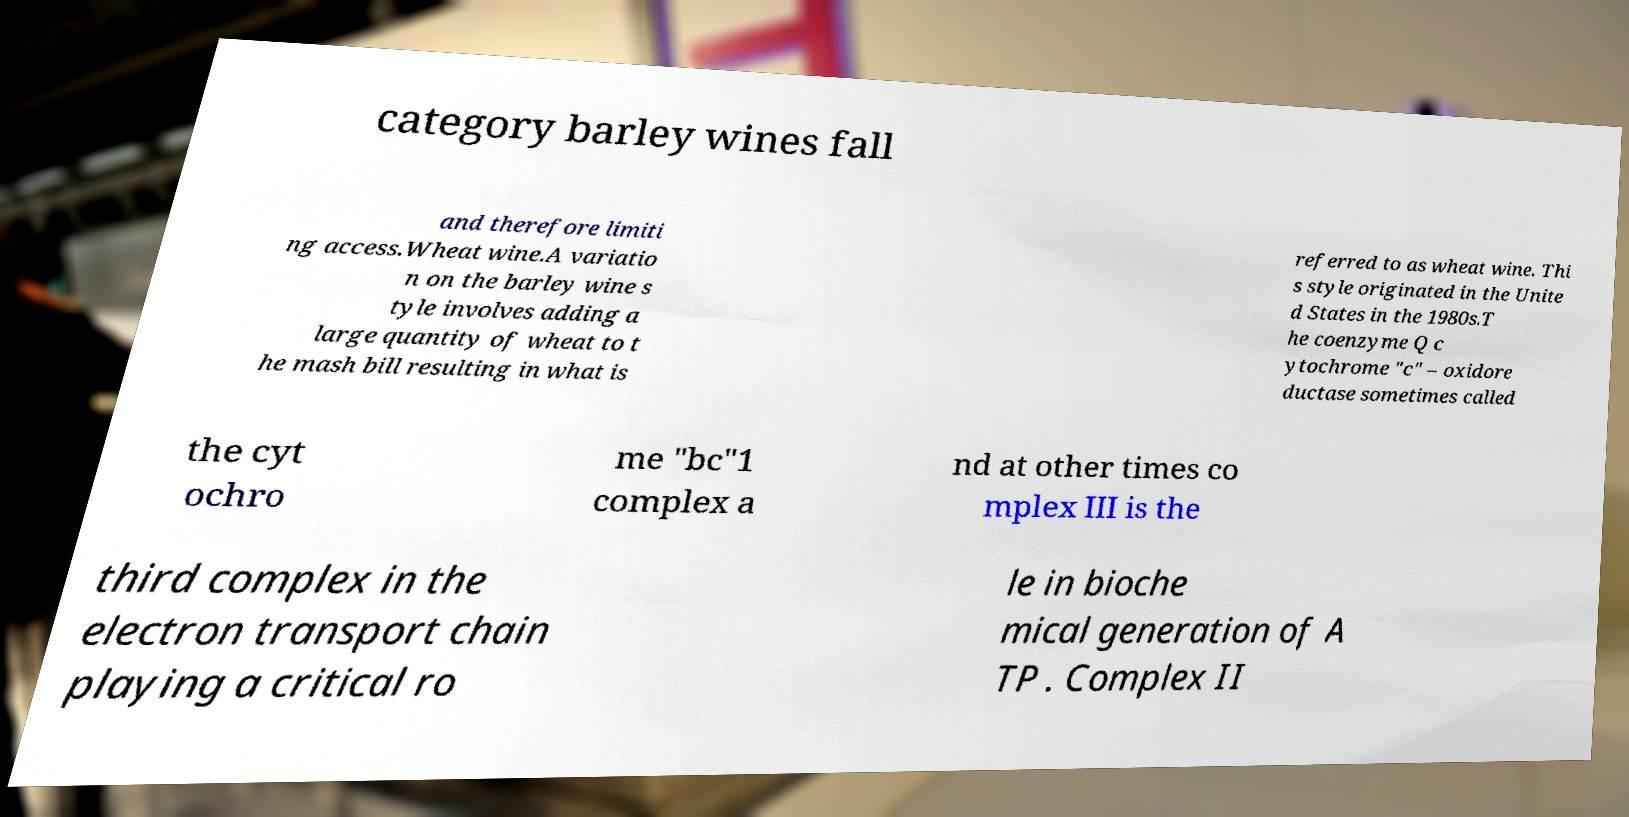Can you read and provide the text displayed in the image?This photo seems to have some interesting text. Can you extract and type it out for me? category barley wines fall and therefore limiti ng access.Wheat wine.A variatio n on the barley wine s tyle involves adding a large quantity of wheat to t he mash bill resulting in what is referred to as wheat wine. Thi s style originated in the Unite d States in the 1980s.T he coenzyme Q c ytochrome "c" – oxidore ductase sometimes called the cyt ochro me "bc"1 complex a nd at other times co mplex III is the third complex in the electron transport chain playing a critical ro le in bioche mical generation of A TP . Complex II 